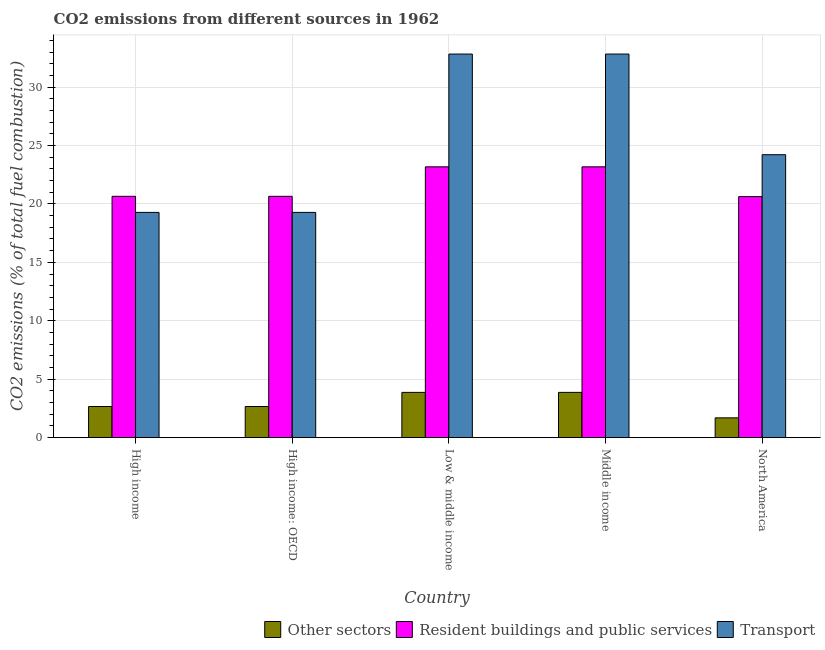How many groups of bars are there?
Make the answer very short. 5. Are the number of bars per tick equal to the number of legend labels?
Provide a short and direct response. Yes. How many bars are there on the 3rd tick from the right?
Offer a terse response. 3. In how many cases, is the number of bars for a given country not equal to the number of legend labels?
Your answer should be very brief. 0. What is the percentage of co2 emissions from transport in Low & middle income?
Offer a very short reply. 32.82. Across all countries, what is the maximum percentage of co2 emissions from resident buildings and public services?
Offer a very short reply. 23.17. Across all countries, what is the minimum percentage of co2 emissions from transport?
Keep it short and to the point. 19.27. What is the total percentage of co2 emissions from transport in the graph?
Offer a terse response. 128.41. What is the difference between the percentage of co2 emissions from other sectors in High income: OECD and that in Middle income?
Your answer should be very brief. -1.21. What is the difference between the percentage of co2 emissions from resident buildings and public services in Low & middle income and the percentage of co2 emissions from other sectors in High income?
Your response must be concise. 20.51. What is the average percentage of co2 emissions from resident buildings and public services per country?
Keep it short and to the point. 21.65. What is the difference between the percentage of co2 emissions from transport and percentage of co2 emissions from other sectors in High income?
Provide a succinct answer. 16.61. In how many countries, is the percentage of co2 emissions from resident buildings and public services greater than 8 %?
Your response must be concise. 5. What is the ratio of the percentage of co2 emissions from other sectors in Middle income to that in North America?
Your answer should be very brief. 2.29. Is the percentage of co2 emissions from resident buildings and public services in High income: OECD less than that in Low & middle income?
Give a very brief answer. Yes. Is the difference between the percentage of co2 emissions from other sectors in High income and Middle income greater than the difference between the percentage of co2 emissions from resident buildings and public services in High income and Middle income?
Offer a very short reply. Yes. What is the difference between the highest and the second highest percentage of co2 emissions from resident buildings and public services?
Provide a short and direct response. 0. What is the difference between the highest and the lowest percentage of co2 emissions from other sectors?
Your response must be concise. 2.18. In how many countries, is the percentage of co2 emissions from other sectors greater than the average percentage of co2 emissions from other sectors taken over all countries?
Make the answer very short. 2. Is the sum of the percentage of co2 emissions from resident buildings and public services in High income: OECD and Middle income greater than the maximum percentage of co2 emissions from transport across all countries?
Your answer should be very brief. Yes. What does the 2nd bar from the left in North America represents?
Offer a very short reply. Resident buildings and public services. What does the 1st bar from the right in Low & middle income represents?
Give a very brief answer. Transport. Are all the bars in the graph horizontal?
Ensure brevity in your answer.  No. Are the values on the major ticks of Y-axis written in scientific E-notation?
Your answer should be very brief. No. Does the graph contain grids?
Give a very brief answer. Yes. Where does the legend appear in the graph?
Keep it short and to the point. Bottom right. How many legend labels are there?
Offer a terse response. 3. What is the title of the graph?
Offer a terse response. CO2 emissions from different sources in 1962. What is the label or title of the X-axis?
Give a very brief answer. Country. What is the label or title of the Y-axis?
Provide a succinct answer. CO2 emissions (% of total fuel combustion). What is the CO2 emissions (% of total fuel combustion) of Other sectors in High income?
Your response must be concise. 2.66. What is the CO2 emissions (% of total fuel combustion) in Resident buildings and public services in High income?
Your answer should be very brief. 20.65. What is the CO2 emissions (% of total fuel combustion) of Transport in High income?
Your response must be concise. 19.27. What is the CO2 emissions (% of total fuel combustion) of Other sectors in High income: OECD?
Provide a succinct answer. 2.66. What is the CO2 emissions (% of total fuel combustion) of Resident buildings and public services in High income: OECD?
Your response must be concise. 20.65. What is the CO2 emissions (% of total fuel combustion) of Transport in High income: OECD?
Keep it short and to the point. 19.27. What is the CO2 emissions (% of total fuel combustion) in Other sectors in Low & middle income?
Provide a succinct answer. 3.87. What is the CO2 emissions (% of total fuel combustion) of Resident buildings and public services in Low & middle income?
Offer a very short reply. 23.17. What is the CO2 emissions (% of total fuel combustion) of Transport in Low & middle income?
Provide a short and direct response. 32.82. What is the CO2 emissions (% of total fuel combustion) of Other sectors in Middle income?
Make the answer very short. 3.87. What is the CO2 emissions (% of total fuel combustion) of Resident buildings and public services in Middle income?
Make the answer very short. 23.17. What is the CO2 emissions (% of total fuel combustion) in Transport in Middle income?
Provide a short and direct response. 32.82. What is the CO2 emissions (% of total fuel combustion) of Other sectors in North America?
Give a very brief answer. 1.69. What is the CO2 emissions (% of total fuel combustion) in Resident buildings and public services in North America?
Offer a terse response. 20.62. What is the CO2 emissions (% of total fuel combustion) of Transport in North America?
Offer a terse response. 24.21. Across all countries, what is the maximum CO2 emissions (% of total fuel combustion) in Other sectors?
Provide a succinct answer. 3.87. Across all countries, what is the maximum CO2 emissions (% of total fuel combustion) in Resident buildings and public services?
Your response must be concise. 23.17. Across all countries, what is the maximum CO2 emissions (% of total fuel combustion) of Transport?
Give a very brief answer. 32.82. Across all countries, what is the minimum CO2 emissions (% of total fuel combustion) in Other sectors?
Offer a very short reply. 1.69. Across all countries, what is the minimum CO2 emissions (% of total fuel combustion) of Resident buildings and public services?
Offer a very short reply. 20.62. Across all countries, what is the minimum CO2 emissions (% of total fuel combustion) of Transport?
Provide a succinct answer. 19.27. What is the total CO2 emissions (% of total fuel combustion) of Other sectors in the graph?
Ensure brevity in your answer.  14.76. What is the total CO2 emissions (% of total fuel combustion) of Resident buildings and public services in the graph?
Your answer should be very brief. 108.27. What is the total CO2 emissions (% of total fuel combustion) in Transport in the graph?
Offer a terse response. 128.41. What is the difference between the CO2 emissions (% of total fuel combustion) in Resident buildings and public services in High income and that in High income: OECD?
Your answer should be compact. 0. What is the difference between the CO2 emissions (% of total fuel combustion) of Other sectors in High income and that in Low & middle income?
Offer a very short reply. -1.21. What is the difference between the CO2 emissions (% of total fuel combustion) of Resident buildings and public services in High income and that in Low & middle income?
Your response must be concise. -2.52. What is the difference between the CO2 emissions (% of total fuel combustion) in Transport in High income and that in Low & middle income?
Your answer should be compact. -13.55. What is the difference between the CO2 emissions (% of total fuel combustion) of Other sectors in High income and that in Middle income?
Your response must be concise. -1.21. What is the difference between the CO2 emissions (% of total fuel combustion) of Resident buildings and public services in High income and that in Middle income?
Offer a terse response. -2.52. What is the difference between the CO2 emissions (% of total fuel combustion) of Transport in High income and that in Middle income?
Your answer should be compact. -13.55. What is the difference between the CO2 emissions (% of total fuel combustion) in Resident buildings and public services in High income and that in North America?
Keep it short and to the point. 0.03. What is the difference between the CO2 emissions (% of total fuel combustion) of Transport in High income and that in North America?
Your answer should be compact. -4.94. What is the difference between the CO2 emissions (% of total fuel combustion) of Other sectors in High income: OECD and that in Low & middle income?
Your answer should be compact. -1.21. What is the difference between the CO2 emissions (% of total fuel combustion) in Resident buildings and public services in High income: OECD and that in Low & middle income?
Your response must be concise. -2.52. What is the difference between the CO2 emissions (% of total fuel combustion) of Transport in High income: OECD and that in Low & middle income?
Give a very brief answer. -13.55. What is the difference between the CO2 emissions (% of total fuel combustion) in Other sectors in High income: OECD and that in Middle income?
Ensure brevity in your answer.  -1.21. What is the difference between the CO2 emissions (% of total fuel combustion) in Resident buildings and public services in High income: OECD and that in Middle income?
Provide a short and direct response. -2.52. What is the difference between the CO2 emissions (% of total fuel combustion) of Transport in High income: OECD and that in Middle income?
Ensure brevity in your answer.  -13.55. What is the difference between the CO2 emissions (% of total fuel combustion) of Other sectors in High income: OECD and that in North America?
Your response must be concise. 0.97. What is the difference between the CO2 emissions (% of total fuel combustion) of Resident buildings and public services in High income: OECD and that in North America?
Your response must be concise. 0.03. What is the difference between the CO2 emissions (% of total fuel combustion) in Transport in High income: OECD and that in North America?
Ensure brevity in your answer.  -4.94. What is the difference between the CO2 emissions (% of total fuel combustion) of Resident buildings and public services in Low & middle income and that in Middle income?
Provide a short and direct response. 0. What is the difference between the CO2 emissions (% of total fuel combustion) in Transport in Low & middle income and that in Middle income?
Provide a succinct answer. 0. What is the difference between the CO2 emissions (% of total fuel combustion) of Other sectors in Low & middle income and that in North America?
Offer a terse response. 2.18. What is the difference between the CO2 emissions (% of total fuel combustion) of Resident buildings and public services in Low & middle income and that in North America?
Provide a short and direct response. 2.55. What is the difference between the CO2 emissions (% of total fuel combustion) of Transport in Low & middle income and that in North America?
Keep it short and to the point. 8.61. What is the difference between the CO2 emissions (% of total fuel combustion) in Other sectors in Middle income and that in North America?
Give a very brief answer. 2.18. What is the difference between the CO2 emissions (% of total fuel combustion) of Resident buildings and public services in Middle income and that in North America?
Provide a succinct answer. 2.55. What is the difference between the CO2 emissions (% of total fuel combustion) in Transport in Middle income and that in North America?
Offer a terse response. 8.61. What is the difference between the CO2 emissions (% of total fuel combustion) in Other sectors in High income and the CO2 emissions (% of total fuel combustion) in Resident buildings and public services in High income: OECD?
Give a very brief answer. -17.99. What is the difference between the CO2 emissions (% of total fuel combustion) of Other sectors in High income and the CO2 emissions (% of total fuel combustion) of Transport in High income: OECD?
Your answer should be very brief. -16.61. What is the difference between the CO2 emissions (% of total fuel combustion) of Resident buildings and public services in High income and the CO2 emissions (% of total fuel combustion) of Transport in High income: OECD?
Your answer should be compact. 1.38. What is the difference between the CO2 emissions (% of total fuel combustion) of Other sectors in High income and the CO2 emissions (% of total fuel combustion) of Resident buildings and public services in Low & middle income?
Make the answer very short. -20.51. What is the difference between the CO2 emissions (% of total fuel combustion) in Other sectors in High income and the CO2 emissions (% of total fuel combustion) in Transport in Low & middle income?
Give a very brief answer. -30.16. What is the difference between the CO2 emissions (% of total fuel combustion) of Resident buildings and public services in High income and the CO2 emissions (% of total fuel combustion) of Transport in Low & middle income?
Provide a succinct answer. -12.17. What is the difference between the CO2 emissions (% of total fuel combustion) of Other sectors in High income and the CO2 emissions (% of total fuel combustion) of Resident buildings and public services in Middle income?
Provide a succinct answer. -20.51. What is the difference between the CO2 emissions (% of total fuel combustion) in Other sectors in High income and the CO2 emissions (% of total fuel combustion) in Transport in Middle income?
Offer a terse response. -30.16. What is the difference between the CO2 emissions (% of total fuel combustion) in Resident buildings and public services in High income and the CO2 emissions (% of total fuel combustion) in Transport in Middle income?
Give a very brief answer. -12.17. What is the difference between the CO2 emissions (% of total fuel combustion) of Other sectors in High income and the CO2 emissions (% of total fuel combustion) of Resident buildings and public services in North America?
Your answer should be compact. -17.96. What is the difference between the CO2 emissions (% of total fuel combustion) in Other sectors in High income and the CO2 emissions (% of total fuel combustion) in Transport in North America?
Provide a succinct answer. -21.55. What is the difference between the CO2 emissions (% of total fuel combustion) of Resident buildings and public services in High income and the CO2 emissions (% of total fuel combustion) of Transport in North America?
Offer a very short reply. -3.56. What is the difference between the CO2 emissions (% of total fuel combustion) in Other sectors in High income: OECD and the CO2 emissions (% of total fuel combustion) in Resident buildings and public services in Low & middle income?
Offer a very short reply. -20.51. What is the difference between the CO2 emissions (% of total fuel combustion) in Other sectors in High income: OECD and the CO2 emissions (% of total fuel combustion) in Transport in Low & middle income?
Offer a very short reply. -30.16. What is the difference between the CO2 emissions (% of total fuel combustion) in Resident buildings and public services in High income: OECD and the CO2 emissions (% of total fuel combustion) in Transport in Low & middle income?
Give a very brief answer. -12.17. What is the difference between the CO2 emissions (% of total fuel combustion) in Other sectors in High income: OECD and the CO2 emissions (% of total fuel combustion) in Resident buildings and public services in Middle income?
Offer a very short reply. -20.51. What is the difference between the CO2 emissions (% of total fuel combustion) of Other sectors in High income: OECD and the CO2 emissions (% of total fuel combustion) of Transport in Middle income?
Provide a short and direct response. -30.16. What is the difference between the CO2 emissions (% of total fuel combustion) of Resident buildings and public services in High income: OECD and the CO2 emissions (% of total fuel combustion) of Transport in Middle income?
Your answer should be compact. -12.17. What is the difference between the CO2 emissions (% of total fuel combustion) of Other sectors in High income: OECD and the CO2 emissions (% of total fuel combustion) of Resident buildings and public services in North America?
Provide a succinct answer. -17.96. What is the difference between the CO2 emissions (% of total fuel combustion) of Other sectors in High income: OECD and the CO2 emissions (% of total fuel combustion) of Transport in North America?
Your answer should be compact. -21.55. What is the difference between the CO2 emissions (% of total fuel combustion) of Resident buildings and public services in High income: OECD and the CO2 emissions (% of total fuel combustion) of Transport in North America?
Give a very brief answer. -3.56. What is the difference between the CO2 emissions (% of total fuel combustion) of Other sectors in Low & middle income and the CO2 emissions (% of total fuel combustion) of Resident buildings and public services in Middle income?
Your answer should be compact. -19.3. What is the difference between the CO2 emissions (% of total fuel combustion) in Other sectors in Low & middle income and the CO2 emissions (% of total fuel combustion) in Transport in Middle income?
Give a very brief answer. -28.95. What is the difference between the CO2 emissions (% of total fuel combustion) of Resident buildings and public services in Low & middle income and the CO2 emissions (% of total fuel combustion) of Transport in Middle income?
Make the answer very short. -9.65. What is the difference between the CO2 emissions (% of total fuel combustion) of Other sectors in Low & middle income and the CO2 emissions (% of total fuel combustion) of Resident buildings and public services in North America?
Give a very brief answer. -16.75. What is the difference between the CO2 emissions (% of total fuel combustion) in Other sectors in Low & middle income and the CO2 emissions (% of total fuel combustion) in Transport in North America?
Your answer should be compact. -20.34. What is the difference between the CO2 emissions (% of total fuel combustion) in Resident buildings and public services in Low & middle income and the CO2 emissions (% of total fuel combustion) in Transport in North America?
Offer a terse response. -1.04. What is the difference between the CO2 emissions (% of total fuel combustion) in Other sectors in Middle income and the CO2 emissions (% of total fuel combustion) in Resident buildings and public services in North America?
Keep it short and to the point. -16.75. What is the difference between the CO2 emissions (% of total fuel combustion) in Other sectors in Middle income and the CO2 emissions (% of total fuel combustion) in Transport in North America?
Offer a terse response. -20.34. What is the difference between the CO2 emissions (% of total fuel combustion) in Resident buildings and public services in Middle income and the CO2 emissions (% of total fuel combustion) in Transport in North America?
Your answer should be compact. -1.04. What is the average CO2 emissions (% of total fuel combustion) of Other sectors per country?
Make the answer very short. 2.95. What is the average CO2 emissions (% of total fuel combustion) in Resident buildings and public services per country?
Offer a terse response. 21.65. What is the average CO2 emissions (% of total fuel combustion) of Transport per country?
Your answer should be compact. 25.68. What is the difference between the CO2 emissions (% of total fuel combustion) of Other sectors and CO2 emissions (% of total fuel combustion) of Resident buildings and public services in High income?
Offer a very short reply. -17.99. What is the difference between the CO2 emissions (% of total fuel combustion) in Other sectors and CO2 emissions (% of total fuel combustion) in Transport in High income?
Your answer should be compact. -16.61. What is the difference between the CO2 emissions (% of total fuel combustion) in Resident buildings and public services and CO2 emissions (% of total fuel combustion) in Transport in High income?
Offer a terse response. 1.38. What is the difference between the CO2 emissions (% of total fuel combustion) in Other sectors and CO2 emissions (% of total fuel combustion) in Resident buildings and public services in High income: OECD?
Your answer should be very brief. -17.99. What is the difference between the CO2 emissions (% of total fuel combustion) of Other sectors and CO2 emissions (% of total fuel combustion) of Transport in High income: OECD?
Your answer should be very brief. -16.61. What is the difference between the CO2 emissions (% of total fuel combustion) of Resident buildings and public services and CO2 emissions (% of total fuel combustion) of Transport in High income: OECD?
Give a very brief answer. 1.38. What is the difference between the CO2 emissions (% of total fuel combustion) in Other sectors and CO2 emissions (% of total fuel combustion) in Resident buildings and public services in Low & middle income?
Keep it short and to the point. -19.3. What is the difference between the CO2 emissions (% of total fuel combustion) of Other sectors and CO2 emissions (% of total fuel combustion) of Transport in Low & middle income?
Make the answer very short. -28.95. What is the difference between the CO2 emissions (% of total fuel combustion) in Resident buildings and public services and CO2 emissions (% of total fuel combustion) in Transport in Low & middle income?
Your answer should be compact. -9.65. What is the difference between the CO2 emissions (% of total fuel combustion) in Other sectors and CO2 emissions (% of total fuel combustion) in Resident buildings and public services in Middle income?
Your response must be concise. -19.3. What is the difference between the CO2 emissions (% of total fuel combustion) in Other sectors and CO2 emissions (% of total fuel combustion) in Transport in Middle income?
Give a very brief answer. -28.95. What is the difference between the CO2 emissions (% of total fuel combustion) in Resident buildings and public services and CO2 emissions (% of total fuel combustion) in Transport in Middle income?
Offer a very short reply. -9.65. What is the difference between the CO2 emissions (% of total fuel combustion) of Other sectors and CO2 emissions (% of total fuel combustion) of Resident buildings and public services in North America?
Provide a short and direct response. -18.93. What is the difference between the CO2 emissions (% of total fuel combustion) of Other sectors and CO2 emissions (% of total fuel combustion) of Transport in North America?
Ensure brevity in your answer.  -22.52. What is the difference between the CO2 emissions (% of total fuel combustion) of Resident buildings and public services and CO2 emissions (% of total fuel combustion) of Transport in North America?
Provide a succinct answer. -3.59. What is the ratio of the CO2 emissions (% of total fuel combustion) in Transport in High income to that in High income: OECD?
Make the answer very short. 1. What is the ratio of the CO2 emissions (% of total fuel combustion) in Other sectors in High income to that in Low & middle income?
Offer a terse response. 0.69. What is the ratio of the CO2 emissions (% of total fuel combustion) of Resident buildings and public services in High income to that in Low & middle income?
Offer a terse response. 0.89. What is the ratio of the CO2 emissions (% of total fuel combustion) in Transport in High income to that in Low & middle income?
Provide a short and direct response. 0.59. What is the ratio of the CO2 emissions (% of total fuel combustion) of Other sectors in High income to that in Middle income?
Offer a terse response. 0.69. What is the ratio of the CO2 emissions (% of total fuel combustion) in Resident buildings and public services in High income to that in Middle income?
Keep it short and to the point. 0.89. What is the ratio of the CO2 emissions (% of total fuel combustion) of Transport in High income to that in Middle income?
Offer a very short reply. 0.59. What is the ratio of the CO2 emissions (% of total fuel combustion) in Other sectors in High income to that in North America?
Ensure brevity in your answer.  1.57. What is the ratio of the CO2 emissions (% of total fuel combustion) of Transport in High income to that in North America?
Give a very brief answer. 0.8. What is the ratio of the CO2 emissions (% of total fuel combustion) in Other sectors in High income: OECD to that in Low & middle income?
Provide a short and direct response. 0.69. What is the ratio of the CO2 emissions (% of total fuel combustion) of Resident buildings and public services in High income: OECD to that in Low & middle income?
Your answer should be very brief. 0.89. What is the ratio of the CO2 emissions (% of total fuel combustion) in Transport in High income: OECD to that in Low & middle income?
Offer a terse response. 0.59. What is the ratio of the CO2 emissions (% of total fuel combustion) of Other sectors in High income: OECD to that in Middle income?
Ensure brevity in your answer.  0.69. What is the ratio of the CO2 emissions (% of total fuel combustion) of Resident buildings and public services in High income: OECD to that in Middle income?
Ensure brevity in your answer.  0.89. What is the ratio of the CO2 emissions (% of total fuel combustion) of Transport in High income: OECD to that in Middle income?
Make the answer very short. 0.59. What is the ratio of the CO2 emissions (% of total fuel combustion) of Other sectors in High income: OECD to that in North America?
Your answer should be compact. 1.57. What is the ratio of the CO2 emissions (% of total fuel combustion) in Transport in High income: OECD to that in North America?
Provide a short and direct response. 0.8. What is the ratio of the CO2 emissions (% of total fuel combustion) of Resident buildings and public services in Low & middle income to that in Middle income?
Your response must be concise. 1. What is the ratio of the CO2 emissions (% of total fuel combustion) of Transport in Low & middle income to that in Middle income?
Offer a very short reply. 1. What is the ratio of the CO2 emissions (% of total fuel combustion) of Other sectors in Low & middle income to that in North America?
Offer a terse response. 2.29. What is the ratio of the CO2 emissions (% of total fuel combustion) of Resident buildings and public services in Low & middle income to that in North America?
Keep it short and to the point. 1.12. What is the ratio of the CO2 emissions (% of total fuel combustion) in Transport in Low & middle income to that in North America?
Your response must be concise. 1.36. What is the ratio of the CO2 emissions (% of total fuel combustion) of Other sectors in Middle income to that in North America?
Keep it short and to the point. 2.29. What is the ratio of the CO2 emissions (% of total fuel combustion) in Resident buildings and public services in Middle income to that in North America?
Give a very brief answer. 1.12. What is the ratio of the CO2 emissions (% of total fuel combustion) of Transport in Middle income to that in North America?
Your answer should be compact. 1.36. What is the difference between the highest and the lowest CO2 emissions (% of total fuel combustion) in Other sectors?
Ensure brevity in your answer.  2.18. What is the difference between the highest and the lowest CO2 emissions (% of total fuel combustion) in Resident buildings and public services?
Offer a terse response. 2.55. What is the difference between the highest and the lowest CO2 emissions (% of total fuel combustion) in Transport?
Provide a succinct answer. 13.55. 